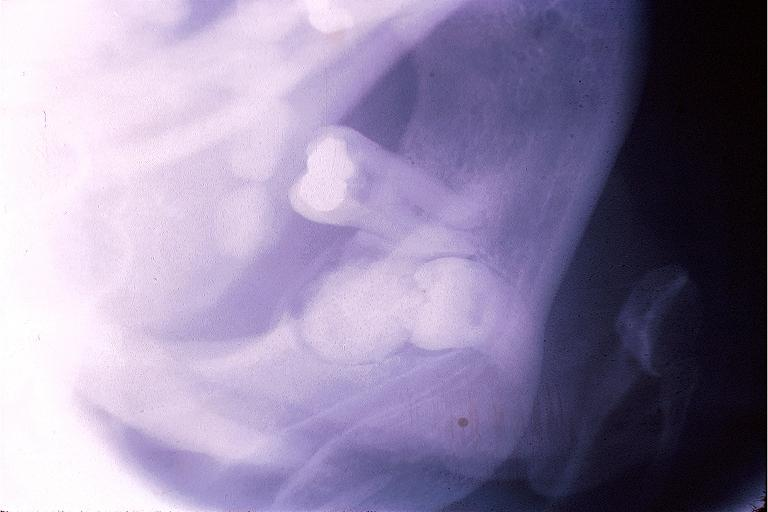does this image show complex odontoma?
Answer the question using a single word or phrase. Yes 